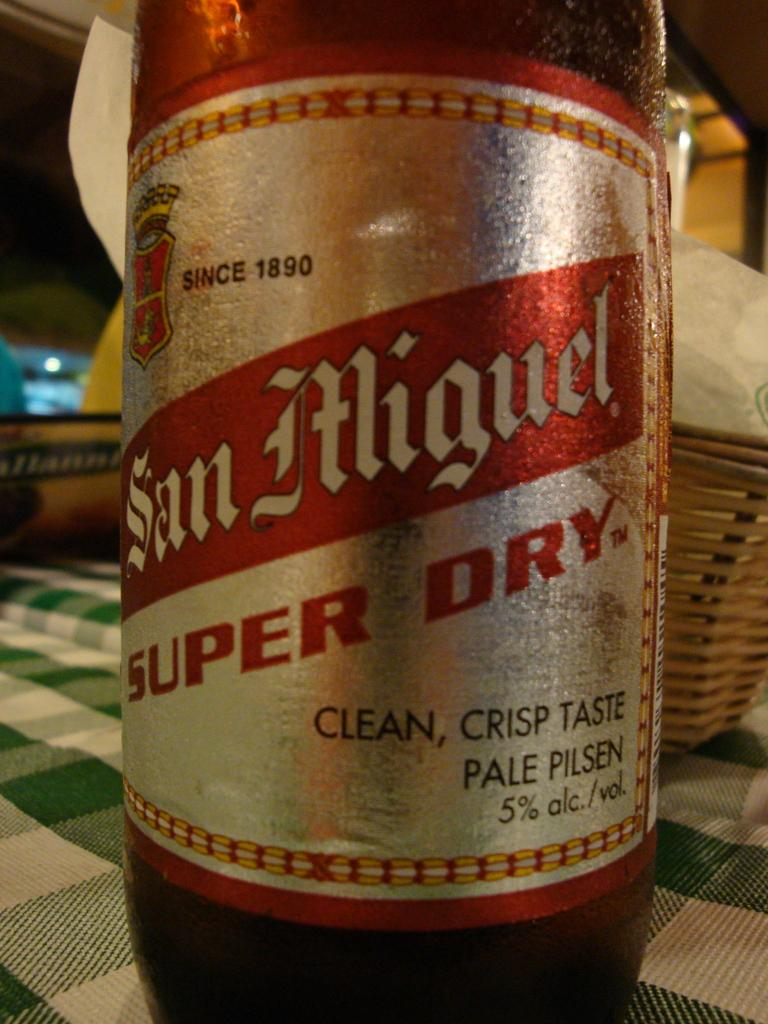Provide a one-sentence caption for the provided image. A San Miguel beverage on top of a table. 